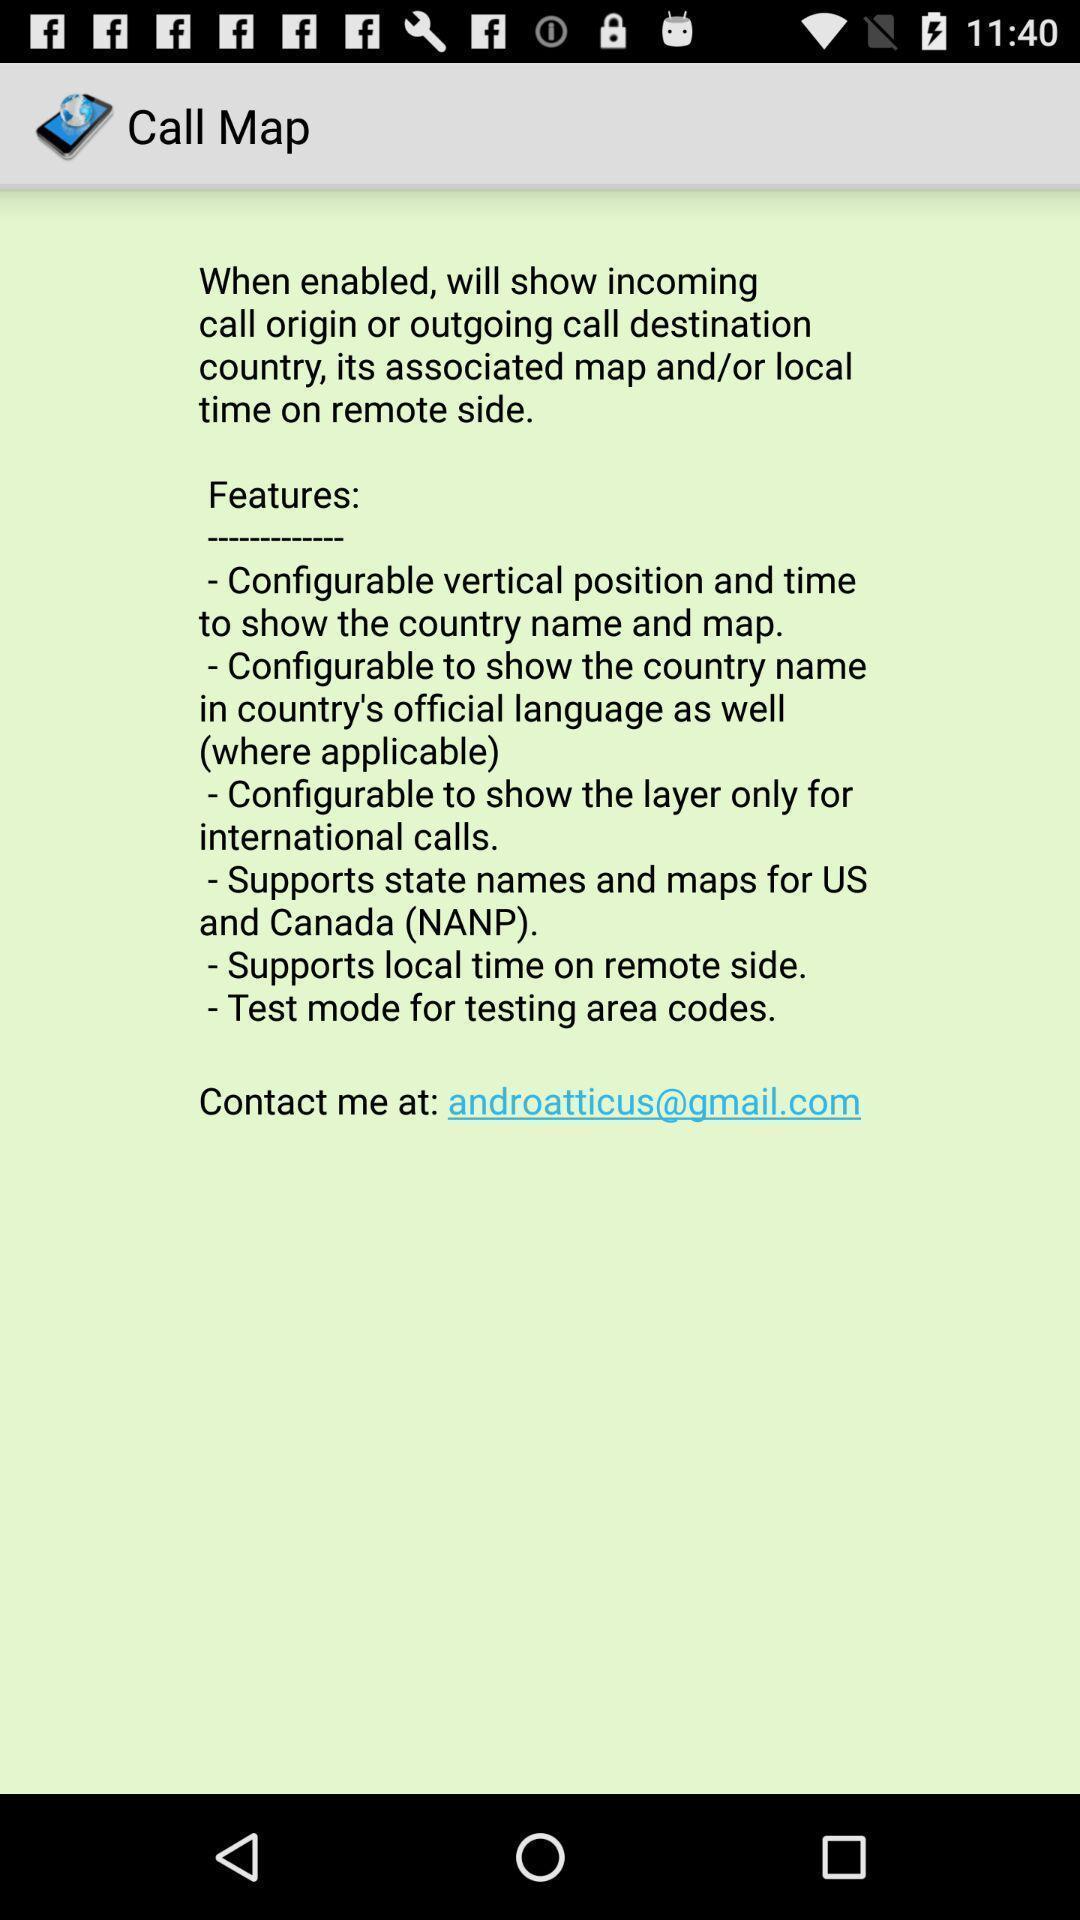Explain what's happening in this screen capture. Page showing features of the app. 